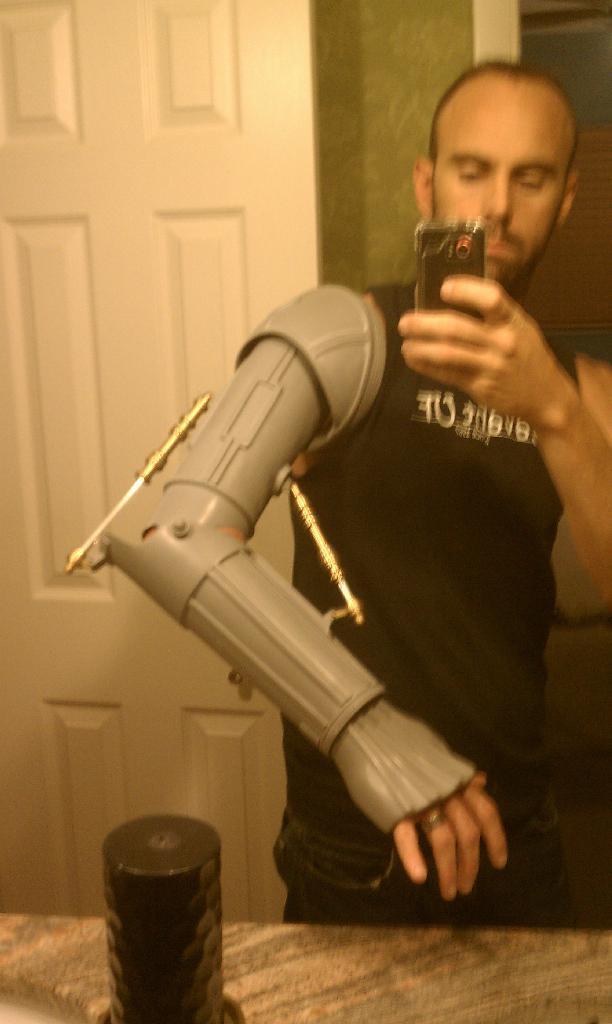Please provide a concise description of this image. In this image we can see a person holding a camera. There is something on his hand. In the back there is a wall and a door. In front of him there is a platform. On that there is a black color object. 